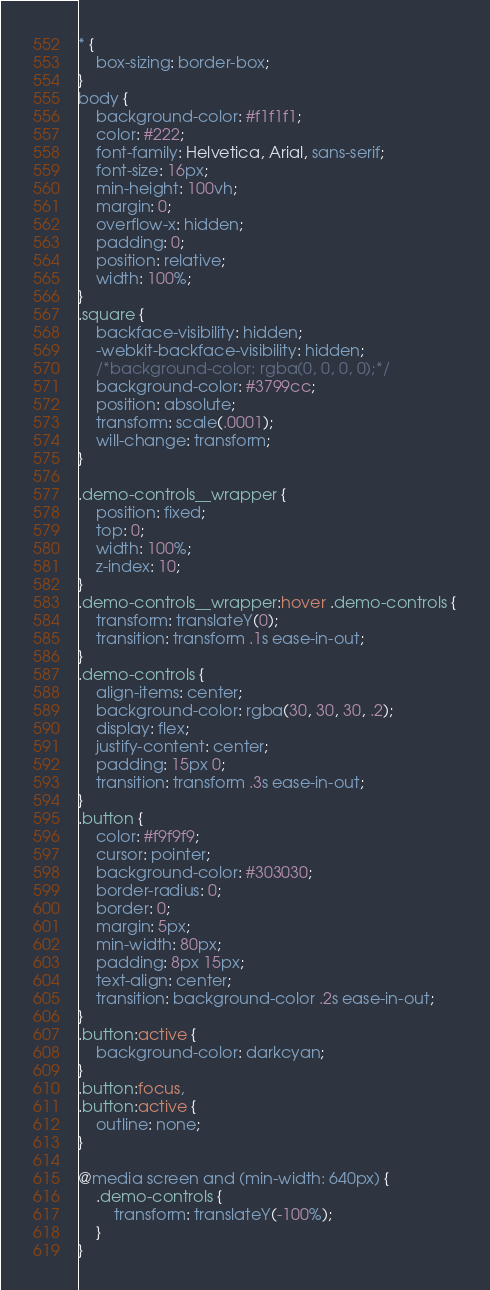Convert code to text. <code><loc_0><loc_0><loc_500><loc_500><_CSS_>* {
    box-sizing: border-box;
}
body {
    background-color: #f1f1f1;
    color: #222;
    font-family: Helvetica, Arial, sans-serif;
    font-size: 16px;
    min-height: 100vh;
    margin: 0;
    overflow-x: hidden;
    padding: 0;
    position: relative;
    width: 100%;
}
.square {
    backface-visibility: hidden;
    -webkit-backface-visibility: hidden;
    /*background-color: rgba(0, 0, 0, 0);*/
    background-color: #3799cc;
    position: absolute;
    transform: scale(.0001);
    will-change: transform;
}

.demo-controls__wrapper {
    position: fixed;
    top: 0;
    width: 100%;
    z-index: 10;
}
.demo-controls__wrapper:hover .demo-controls {
    transform: translateY(0);
    transition: transform .1s ease-in-out;
}
.demo-controls {
    align-items: center;
    background-color: rgba(30, 30, 30, .2);
    display: flex;
    justify-content: center;
    padding: 15px 0;
    transition: transform .3s ease-in-out;
}
.button {
    color: #f9f9f9;
    cursor: pointer;
    background-color: #303030;
    border-radius: 0;
    border: 0;
    margin: 5px;
    min-width: 80px;
    padding: 8px 15px;
    text-align: center;
    transition: background-color .2s ease-in-out;
}
.button:active {
    background-color: darkcyan;
}
.button:focus,
.button:active {
    outline: none;
}

@media screen and (min-width: 640px) {
    .demo-controls {
        transform: translateY(-100%);
    }
}
</code> 